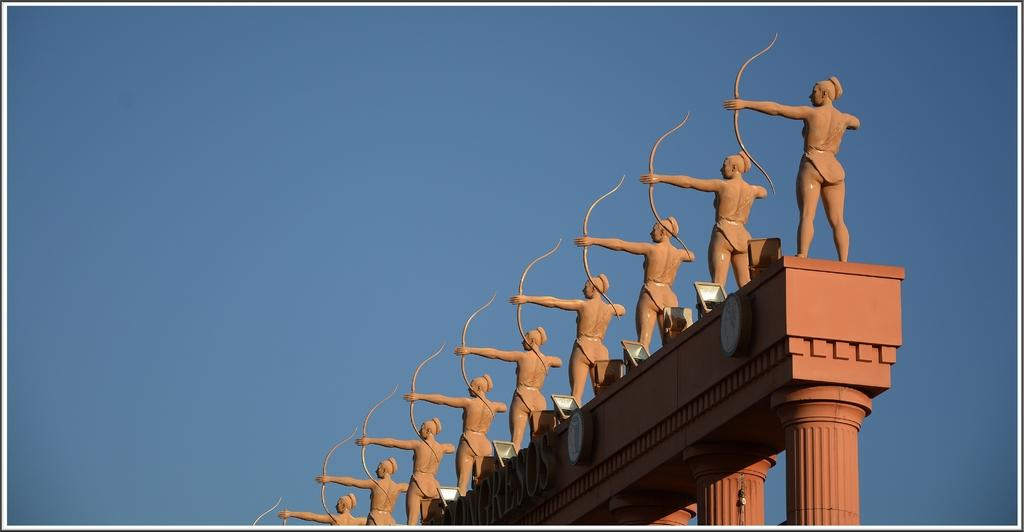What can be seen on the wall in the image? There are many statues on the wall in the image. What architectural features are present in the bottom right of the image? There are pillars in the bottom right of the image. What type of lighting is used to highlight the statues in the image? There are focus lights beside the statues in the image. What can be seen in the background of the image? The sky is visible in the background of the image. How many hands can be seen reaching out of the hole in the image? There is no hole or hand present in the image; it features statues on a wall with focus lights and pillars. 